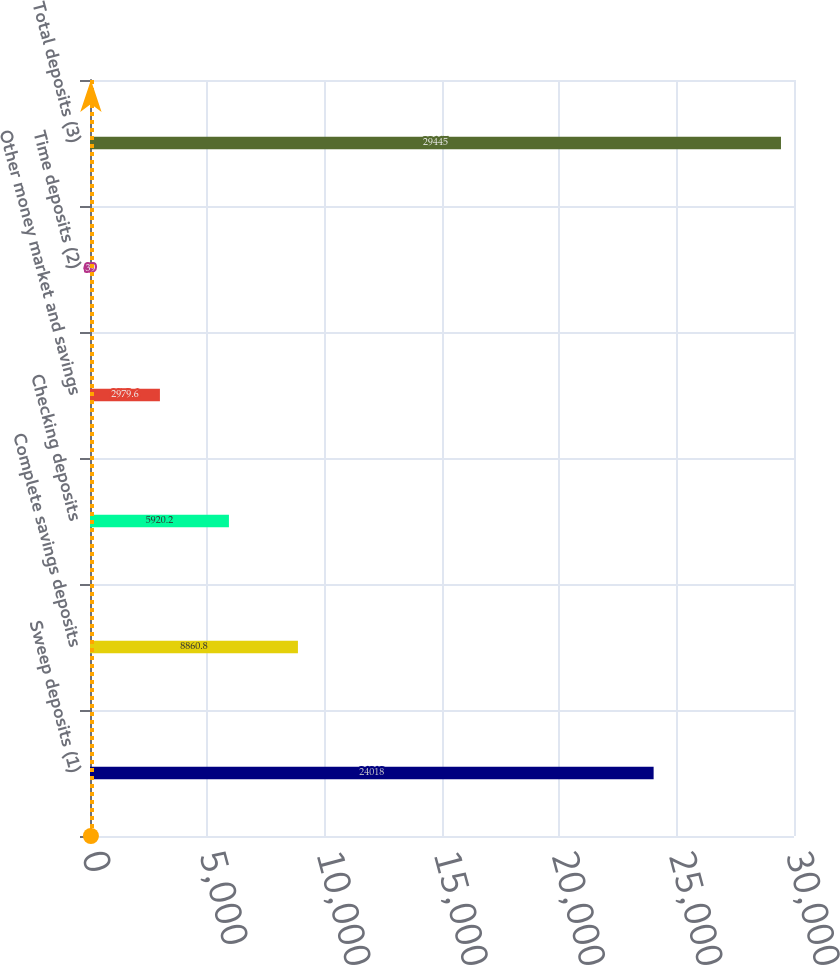Convert chart to OTSL. <chart><loc_0><loc_0><loc_500><loc_500><bar_chart><fcel>Sweep deposits (1)<fcel>Complete savings deposits<fcel>Checking deposits<fcel>Other money market and savings<fcel>Time deposits (2)<fcel>Total deposits (3)<nl><fcel>24018<fcel>8860.8<fcel>5920.2<fcel>2979.6<fcel>39<fcel>29445<nl></chart> 